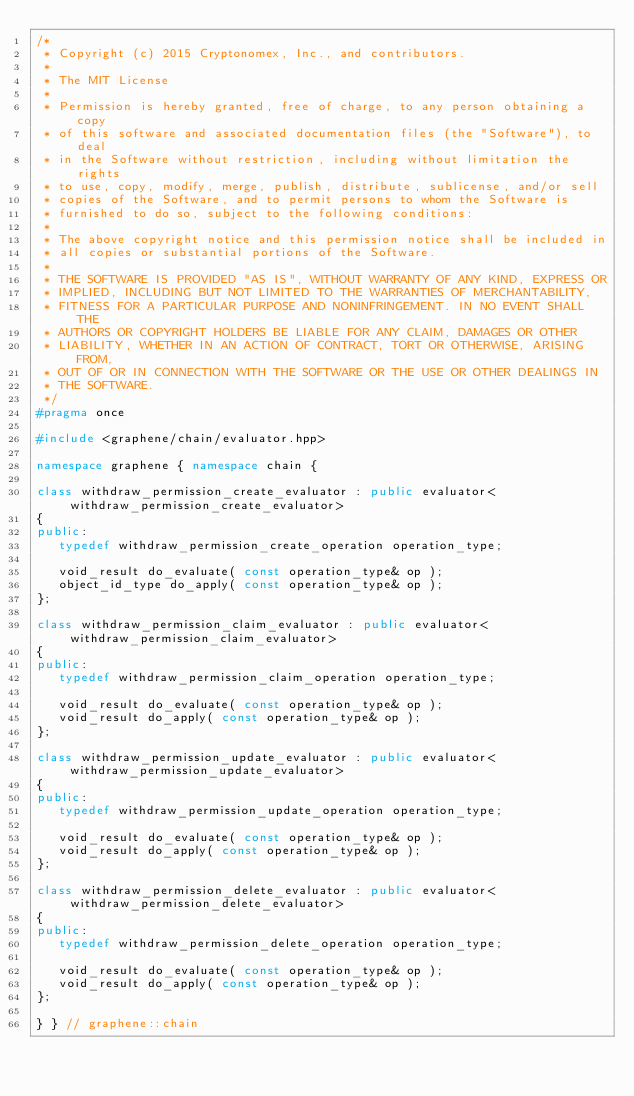<code> <loc_0><loc_0><loc_500><loc_500><_C++_>/*
 * Copyright (c) 2015 Cryptonomex, Inc., and contributors.
 *
 * The MIT License
 *
 * Permission is hereby granted, free of charge, to any person obtaining a copy
 * of this software and associated documentation files (the "Software"), to deal
 * in the Software without restriction, including without limitation the rights
 * to use, copy, modify, merge, publish, distribute, sublicense, and/or sell
 * copies of the Software, and to permit persons to whom the Software is
 * furnished to do so, subject to the following conditions:
 *
 * The above copyright notice and this permission notice shall be included in
 * all copies or substantial portions of the Software.
 *
 * THE SOFTWARE IS PROVIDED "AS IS", WITHOUT WARRANTY OF ANY KIND, EXPRESS OR
 * IMPLIED, INCLUDING BUT NOT LIMITED TO THE WARRANTIES OF MERCHANTABILITY,
 * FITNESS FOR A PARTICULAR PURPOSE AND NONINFRINGEMENT. IN NO EVENT SHALL THE
 * AUTHORS OR COPYRIGHT HOLDERS BE LIABLE FOR ANY CLAIM, DAMAGES OR OTHER
 * LIABILITY, WHETHER IN AN ACTION OF CONTRACT, TORT OR OTHERWISE, ARISING FROM,
 * OUT OF OR IN CONNECTION WITH THE SOFTWARE OR THE USE OR OTHER DEALINGS IN
 * THE SOFTWARE.
 */
#pragma once

#include <graphene/chain/evaluator.hpp>

namespace graphene { namespace chain {

class withdraw_permission_create_evaluator : public evaluator<withdraw_permission_create_evaluator>
{
public:
   typedef withdraw_permission_create_operation operation_type;

   void_result do_evaluate( const operation_type& op );
   object_id_type do_apply( const operation_type& op );
};

class withdraw_permission_claim_evaluator : public evaluator<withdraw_permission_claim_evaluator>
{
public:
   typedef withdraw_permission_claim_operation operation_type;

   void_result do_evaluate( const operation_type& op );
   void_result do_apply( const operation_type& op );
};

class withdraw_permission_update_evaluator : public evaluator<withdraw_permission_update_evaluator>
{
public:
   typedef withdraw_permission_update_operation operation_type;

   void_result do_evaluate( const operation_type& op );
   void_result do_apply( const operation_type& op );
};

class withdraw_permission_delete_evaluator : public evaluator<withdraw_permission_delete_evaluator>
{
public:
   typedef withdraw_permission_delete_operation operation_type;

   void_result do_evaluate( const operation_type& op );
   void_result do_apply( const operation_type& op );
};

} } // graphene::chain
</code> 